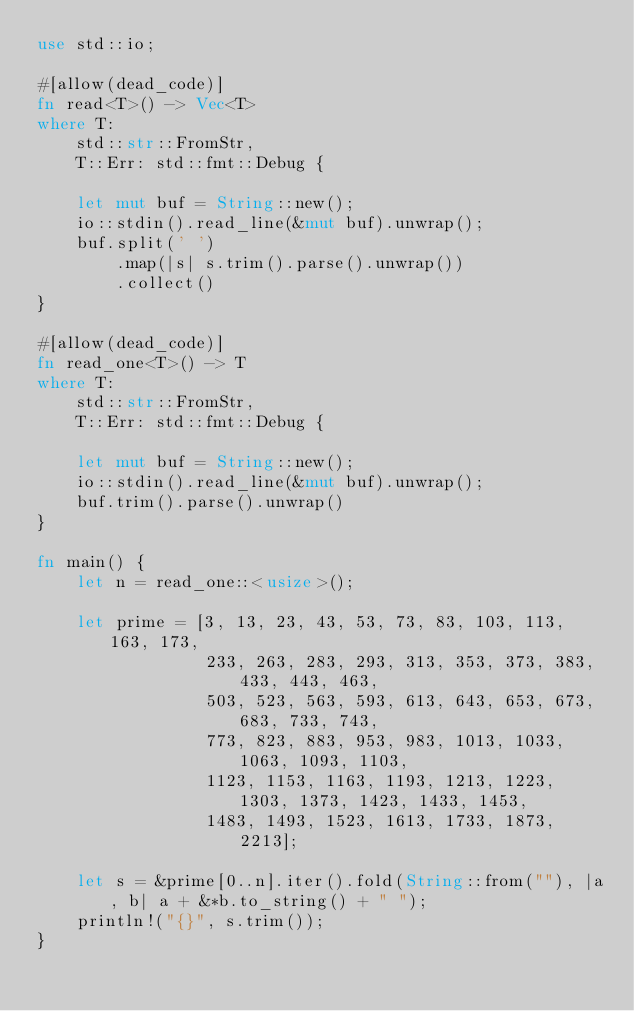Convert code to text. <code><loc_0><loc_0><loc_500><loc_500><_Rust_>use std::io;

#[allow(dead_code)]
fn read<T>() -> Vec<T>
where T:
    std::str::FromStr,
    T::Err: std::fmt::Debug {

    let mut buf = String::new();
    io::stdin().read_line(&mut buf).unwrap();
    buf.split(' ')
        .map(|s| s.trim().parse().unwrap())
        .collect()
}

#[allow(dead_code)]
fn read_one<T>() -> T
where T:
    std::str::FromStr,
    T::Err: std::fmt::Debug {

    let mut buf = String::new();
    io::stdin().read_line(&mut buf).unwrap();
    buf.trim().parse().unwrap()
}

fn main() {
    let n = read_one::<usize>();

    let prime = [3, 13, 23, 43, 53, 73, 83, 103, 113, 163, 173,
                 233, 263, 283, 293, 313, 353, 373, 383, 433, 443, 463,
                 503, 523, 563, 593, 613, 643, 653, 673, 683, 733, 743,
                 773, 823, 883, 953, 983, 1013, 1033, 1063, 1093, 1103,
                 1123, 1153, 1163, 1193, 1213, 1223, 1303, 1373, 1423, 1433, 1453,
                 1483, 1493, 1523, 1613, 1733, 1873, 2213];

    let s = &prime[0..n].iter().fold(String::from(""), |a, b| a + &*b.to_string() + " ");
    println!("{}", s.trim());
}</code> 